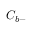Convert formula to latex. <formula><loc_0><loc_0><loc_500><loc_500>C _ { b - }</formula> 